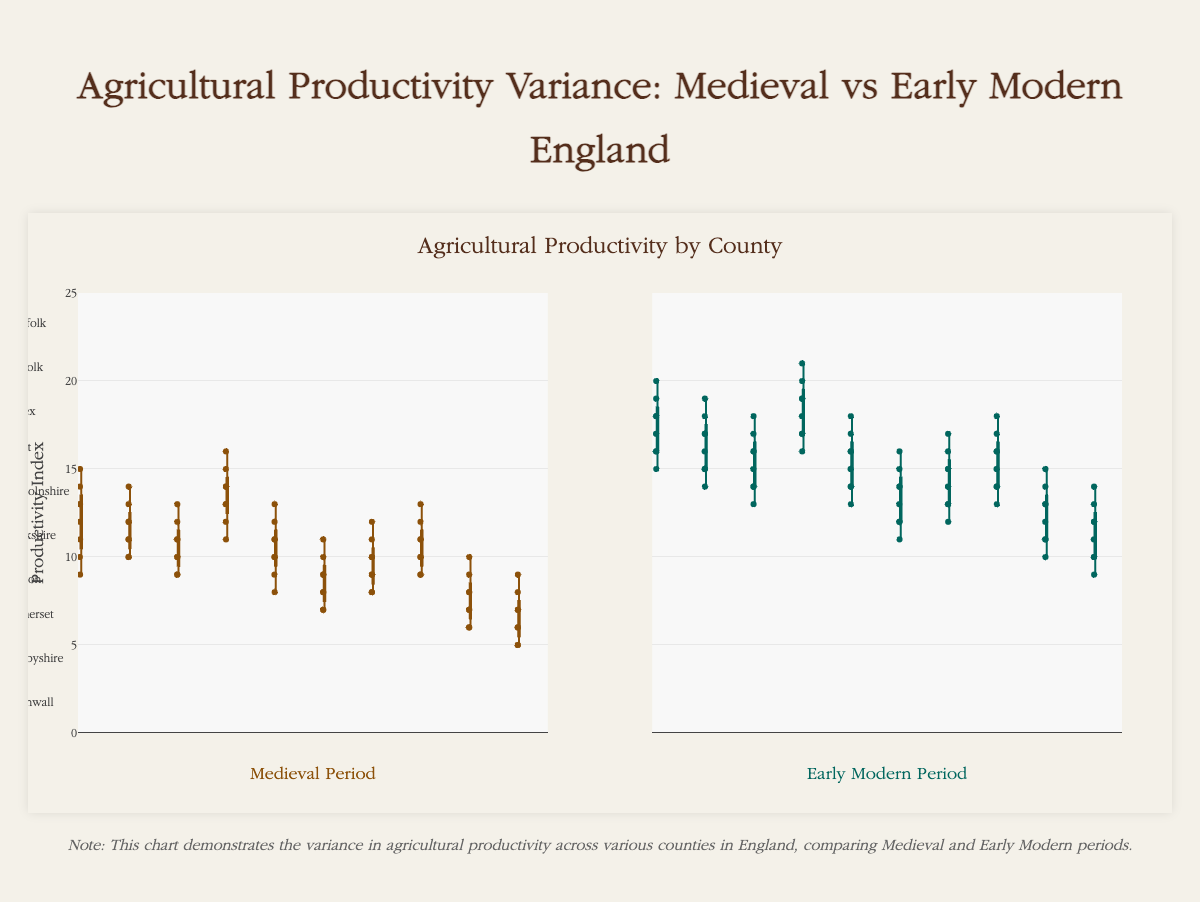What is the title of the chart? The title of the chart is prominently displayed at the top.
Answer: Agricultural Productivity Variance: Medieval vs Early Modern England How does the agricultural productivity in Norfolk compare between the Medieval and Early Modern periods? The box plots show a distinct increase in median and interquartile range from the Medieval to Early Modern periods for Norfolk. The median for the Medieval period is around 12.5, while it increases to around 17 in the Early Modern period.
Answer: It increased Which county shows the highest median agricultural productivity during the Early Modern period? Observing the median lines in the box plots for the Early Modern period, Kent has the highest value.
Answer: Kent What is the interquartile range for Lincolnshire in the Medieval period? The interquartile range is the distance between the 25th percentile (Q1) and the 75th percentile (Q3). For Lincolnshire's Medieval productivity, Q1 is around 9 and Q3 is around 11.5, so the interquartile range is 11.5 - 9 = 2.5.
Answer: 2.5 Which counties show agricultural productivity data points below 10 during the Early Modern period? By examining the box plots, the counties that have any points below 10 for the Early Modern period are Yorkshire, Derbyshire, and Cornwall.
Answer: Yorkshire, Derbyshire, Cornwall How does Kent’s interquartile range change from the Medieval period to the Early Modern period? By examining the size of the boxes in the Kent box plots, the interquartile range increases from approximately 3 in the Medieval period to about 3.5 in the Early Modern period.
Answer: It increased by 0.5 Which county has the smallest median agricultural productivity in the Medieval period? Observing the median lines in the Medieval box plots, Cornwall has the lowest median value which is around 6.
Answer: Cornwall Compare the variance in agricultural productivity for Derbyshire in the Medieval and Early Modern periods. The spread and whiskers of the box plots for Derbyshire in the Medieval period are tighter around the median compared to the Early Modern period, indicating lower variance in the Medieval period compared to a higher variance in the Early Modern period, as it spreads beyond the range of 6 to 10 to a range of 10 to 14.
Answer: Variance increased from Medieval to Early Modern 